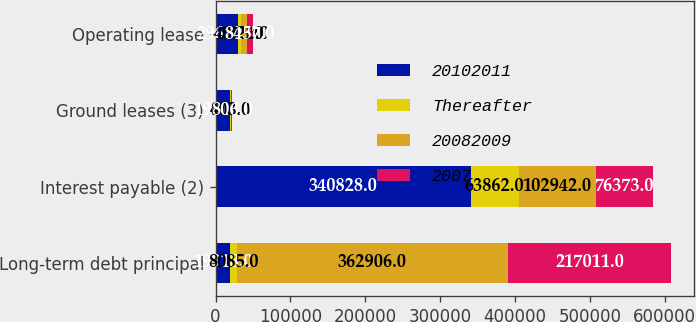Convert chart. <chart><loc_0><loc_0><loc_500><loc_500><stacked_bar_chart><ecel><fcel>Long-term debt principal<fcel>Interest payable (2)<fcel>Ground leases (3)<fcel>Operating lease<nl><fcel>20102011<fcel>19918<fcel>340828<fcel>19918<fcel>29670<nl><fcel>Thereafter<fcel>8085<fcel>63862<fcel>403<fcel>4075<nl><fcel>20082009<fcel>362906<fcel>102942<fcel>806<fcel>7922<nl><fcel>2007<fcel>217011<fcel>76373<fcel>806<fcel>8457<nl></chart> 